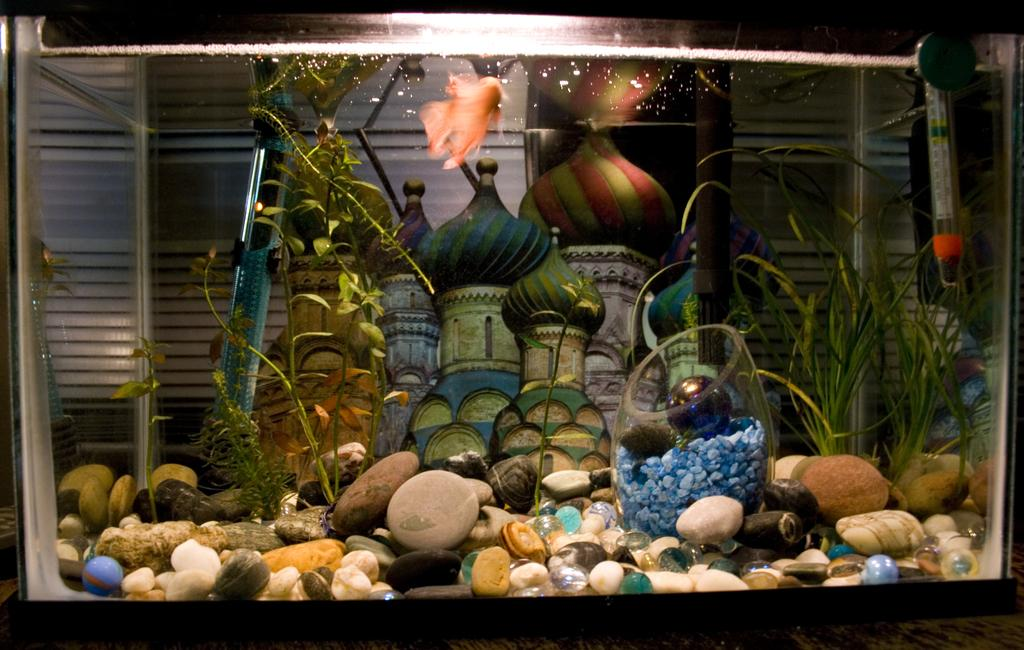What is the main subject of the image? There is an aquarium in the image. What type of laborer can be seen working in the aquarium in the image? There are no laborers present in the image; it only features an aquarium. 